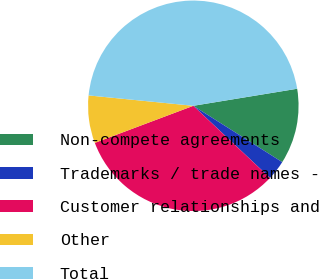Convert chart. <chart><loc_0><loc_0><loc_500><loc_500><pie_chart><fcel>Non-compete agreements<fcel>Trademarks / trade names -<fcel>Customer relationships and<fcel>Other<fcel>Total<nl><fcel>11.58%<fcel>3.02%<fcel>32.27%<fcel>7.3%<fcel>45.84%<nl></chart> 